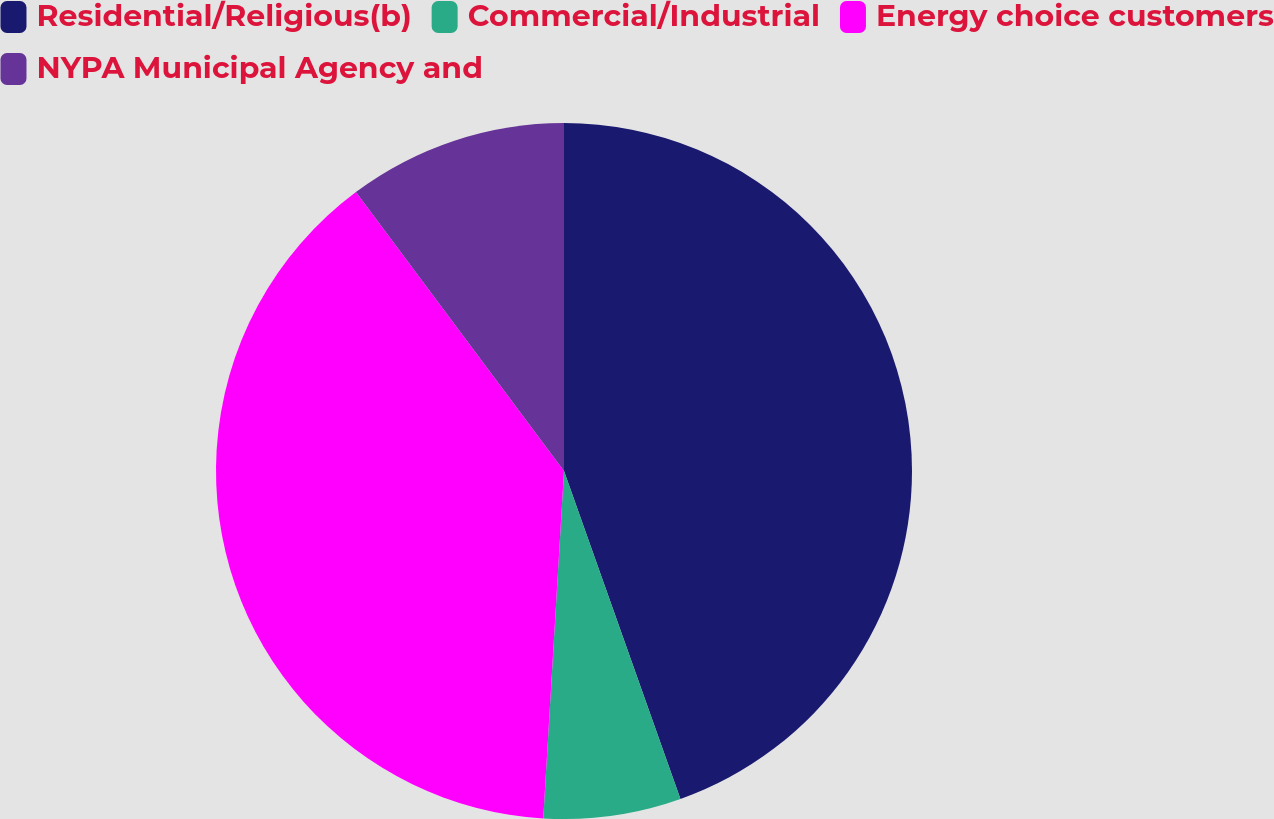<chart> <loc_0><loc_0><loc_500><loc_500><pie_chart><fcel>Residential/Religious(b)<fcel>Commercial/Industrial<fcel>Energy choice customers<fcel>NYPA Municipal Agency and<nl><fcel>44.57%<fcel>6.38%<fcel>38.85%<fcel>10.2%<nl></chart> 